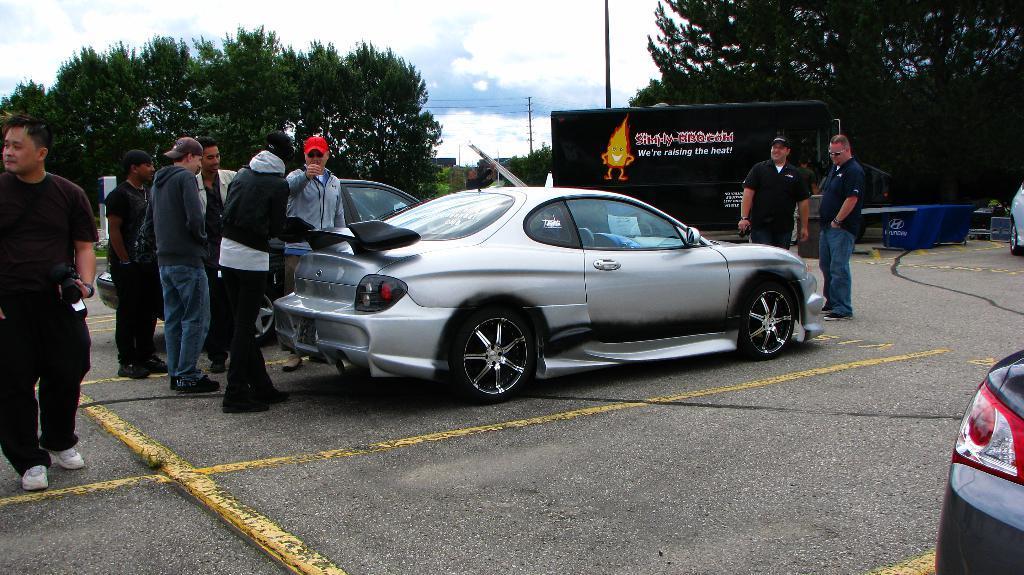In one or two sentences, can you explain what this image depicts? In this image we can see some people and there are few vehicles and we can see a board with some text and a picture and there are some other objects. We can see some trees in the background and at the top we can see the sky with clouds. 